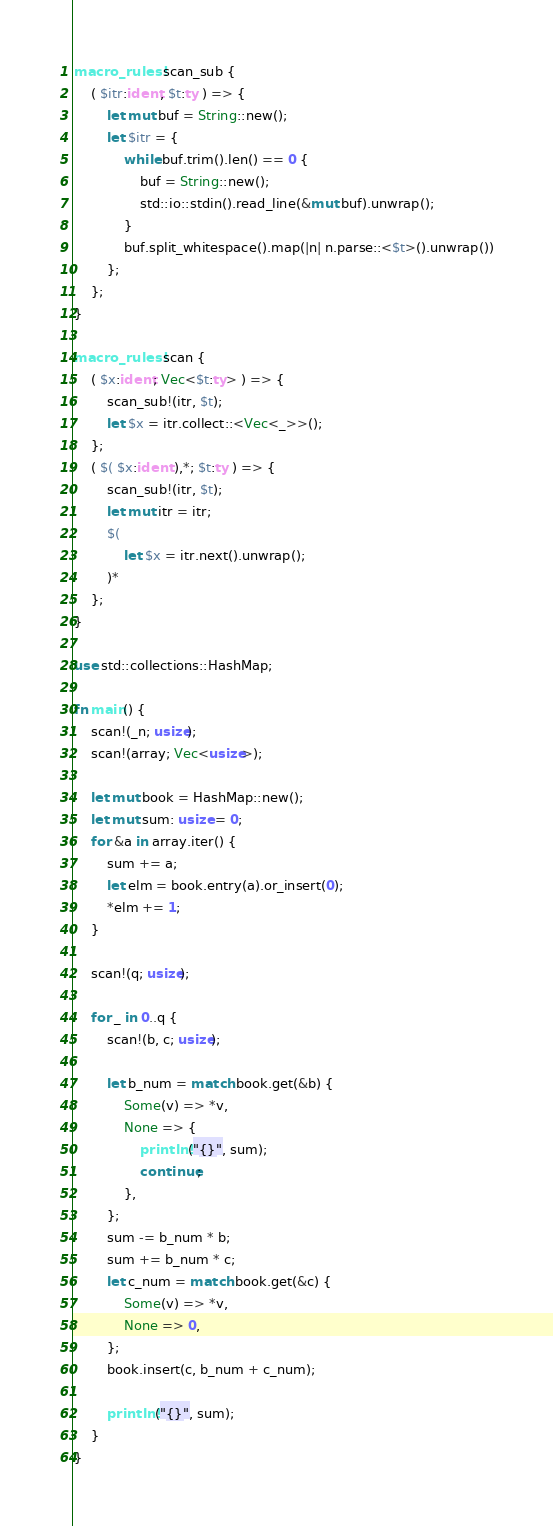<code> <loc_0><loc_0><loc_500><loc_500><_Rust_>macro_rules! scan_sub {
    ( $itr:ident, $t:ty ) => {
        let mut buf = String::new();
        let $itr = {
            while buf.trim().len() == 0 {
                buf = String::new();
                std::io::stdin().read_line(&mut buf).unwrap();
            }
            buf.split_whitespace().map(|n| n.parse::<$t>().unwrap())
        };
    };
}

macro_rules! scan {
    ( $x:ident; Vec<$t:ty> ) => {
        scan_sub!(itr, $t);
        let $x = itr.collect::<Vec<_>>();
    };
    ( $( $x:ident ),*; $t:ty ) => {
        scan_sub!(itr, $t);
        let mut itr = itr;
        $(
            let $x = itr.next().unwrap();
        )*
    };
}

use std::collections::HashMap;

fn main() {
    scan!(_n; usize);
    scan!(array; Vec<usize>);

    let mut book = HashMap::new();
    let mut sum: usize = 0;
    for &a in array.iter() {
        sum += a;
        let elm = book.entry(a).or_insert(0);
        *elm += 1;
    }

    scan!(q; usize);

    for _ in 0..q {
        scan!(b, c; usize);

        let b_num = match book.get(&b) {
            Some(v) => *v,
            None => {
                println!("{}", sum);
                continue;
            },
        };
        sum -= b_num * b;
        sum += b_num * c;
        let c_num = match book.get(&c) {
            Some(v) => *v,
            None => 0,
        };
        book.insert(c, b_num + c_num);

        println!("{}", sum);
    }
}
</code> 